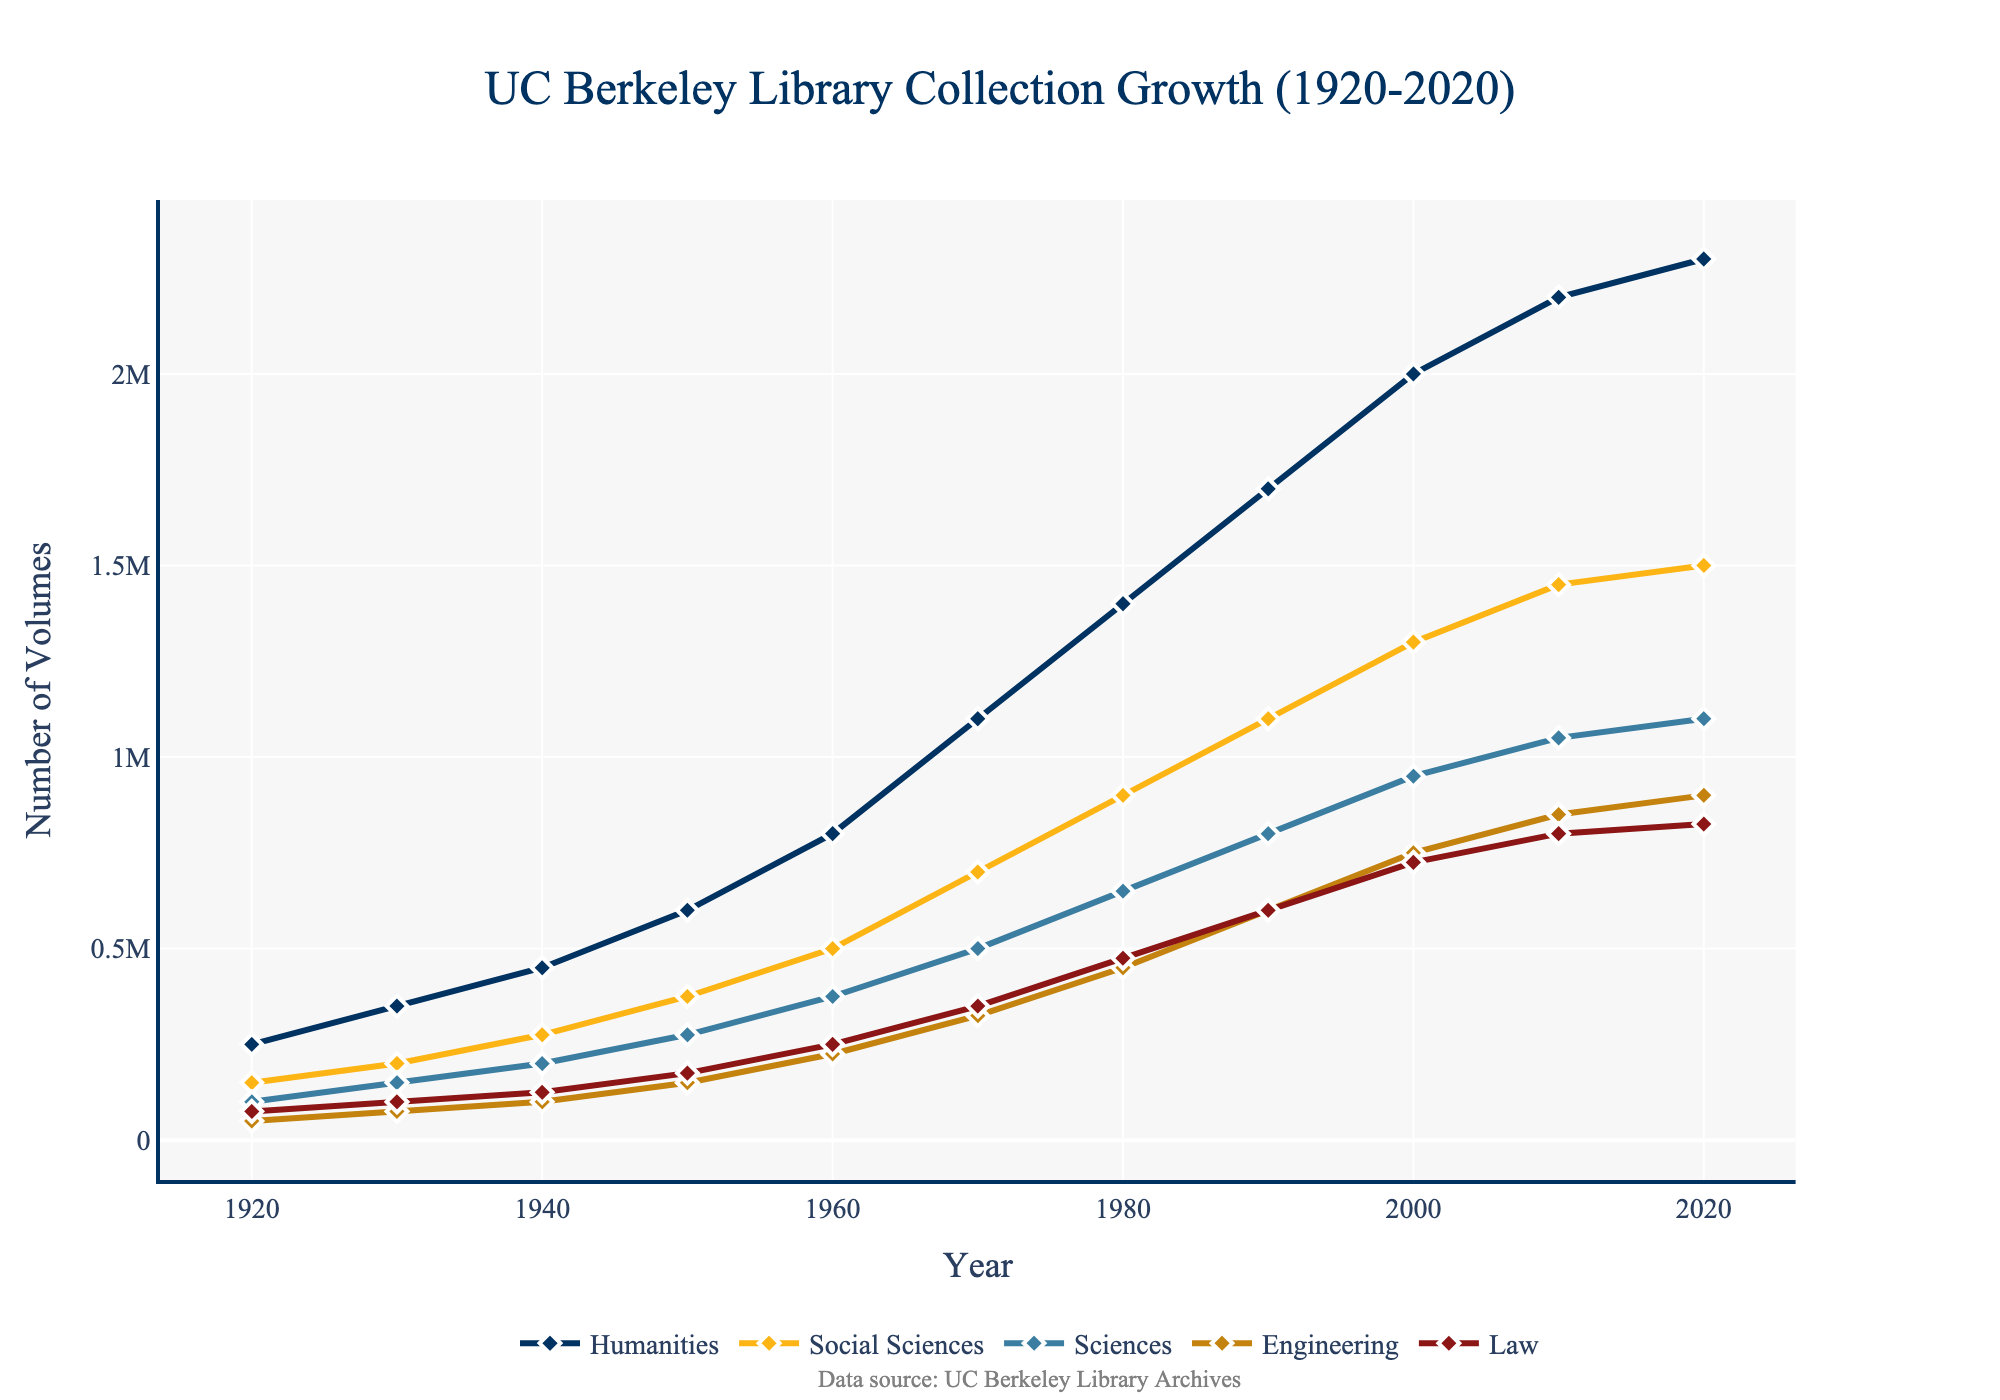Which subject area had the most significant growth in the library collection size between 1920 and 2020? To determine which subject area had the most significant growth, we subtract the 1920 collection size from the 2020 collection size for each subject and compare the differences. Humanities grew from 250,000 to 2,300,000, Social Sciences from 150,000 to 1,500,000, Sciences from 100,000 to 1,100,000, Engineering from 50,000 to 900,000, and Law from 75,000 to 825,000. The Humanities had the largest increase, growing by 2,050,000 volumes.
Answer: Humanities How did the size of the Law library collection change from 1980 to 2020? To find the change, we subtract the 1980 value from the 2020 value for the Law collection. In 1980, the collection size was 475,000 volumes, and in 2020, it was 825,000. Calculating the difference: 825,000 - 475,000 = 350,000.
Answer: Increased by 350,000 Which years show the highest and lowest rates of increase in the Social Sciences collection? We need to find the years with the highest and lowest differences between successive years for Social Sciences. The rate of increase between 1920 and 1930 is 50,000, 1930 and 1940 is 75,000, 1940 and 1950 is 100,000, 1950 and 1960 is 125,000, 1960 and 1970 is 200,000, 1970 and 1980 is 200,000, 1980 and 1990 is 200,000, 1990 and 2000 is 200,000, 2000 and 2010 is 150,000, and 2010 and 2020 is 50,000. The highest rate is between 1960 and 1970, and the lowest rate is between 1920 and 1930, and 2010 and 2020.
Answer: Highest: 1960-1970, Lowest: 1920-1930 and 2010-2020 Among the different subject areas, which one saw a rapid growth in the 1960s and 1970s? We compare the growth in each subject from 1960 to 1970. Humanities increased by 300,000 (800,000 to 1,100,000), Social Sciences by 200,000 (500,000 to 700,000), Sciences by 125,000 (375,000 to 500,000), Engineering by 100,000 (225,000 to 325,000), and Law by 100,000 (250,000 to 350,000). The Humanities experienced the most rapid growth in this period.
Answer: Humanities What is the average collection size for Sciences across all the decades shown? To calculate the average, we sum the collection sizes for Sciences for each decade and divide by the number of data points. The sums are 100,000, 150,000, 200,000, 275,000, 375,000, 500,000, 650,000, 800,000, 950,000, 1,050,000, and 1,100,000, which add up to 6,150,000. There are 11 decades, so the average is 6,150,000 / 11 ≈ 559,090.
Answer: Approximately 559,090 Between Social Sciences and Engineering, which subject had a higher collection size in 2010, and by how much? We compare the collection sizes in 2010 for Social Sciences and Engineering. Social Sciences has 1,450,000 volumes, and Engineering has 850,000 volumes. The difference is 1,450,000 - 850,000 = 600,000.
Answer: Social Sciences by 600,000 Based on the chart, which subject area had the smallest collection size in 1950? We examine the collection sizes for each subject in 1950. Humanities had 600,000, Social Sciences 375,000, Sciences 275,000, Engineering 150,000, and Law 175,000. Engineering had the smallest collection size of 150,000 volumes.
Answer: Engineering What was the overall trend in the Humanities collection size from 1920 to 2020? We observe the values of Humanities from 1920 to 2020: 250,000, 350,000, 450,000, 600,000, 800,000, 1,100,000, 1,400,000, 1,700,000, 2,000,000, 2,200,000, and 2,300,000. The trend shows a consistent and significant increase over the years.
Answer: Consistent and significant increase 